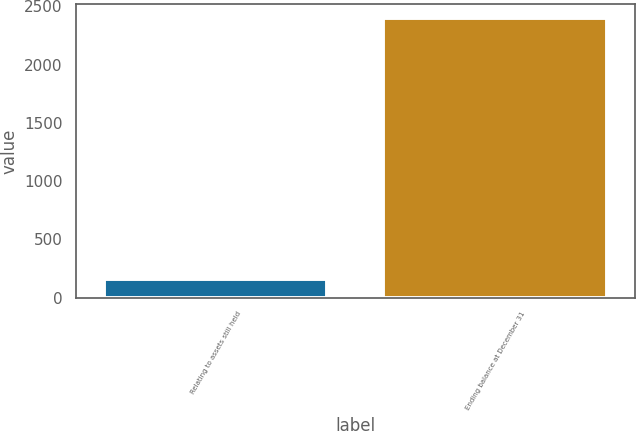Convert chart. <chart><loc_0><loc_0><loc_500><loc_500><bar_chart><fcel>Relating to assets still held<fcel>Ending balance at December 31<nl><fcel>165<fcel>2397<nl></chart> 